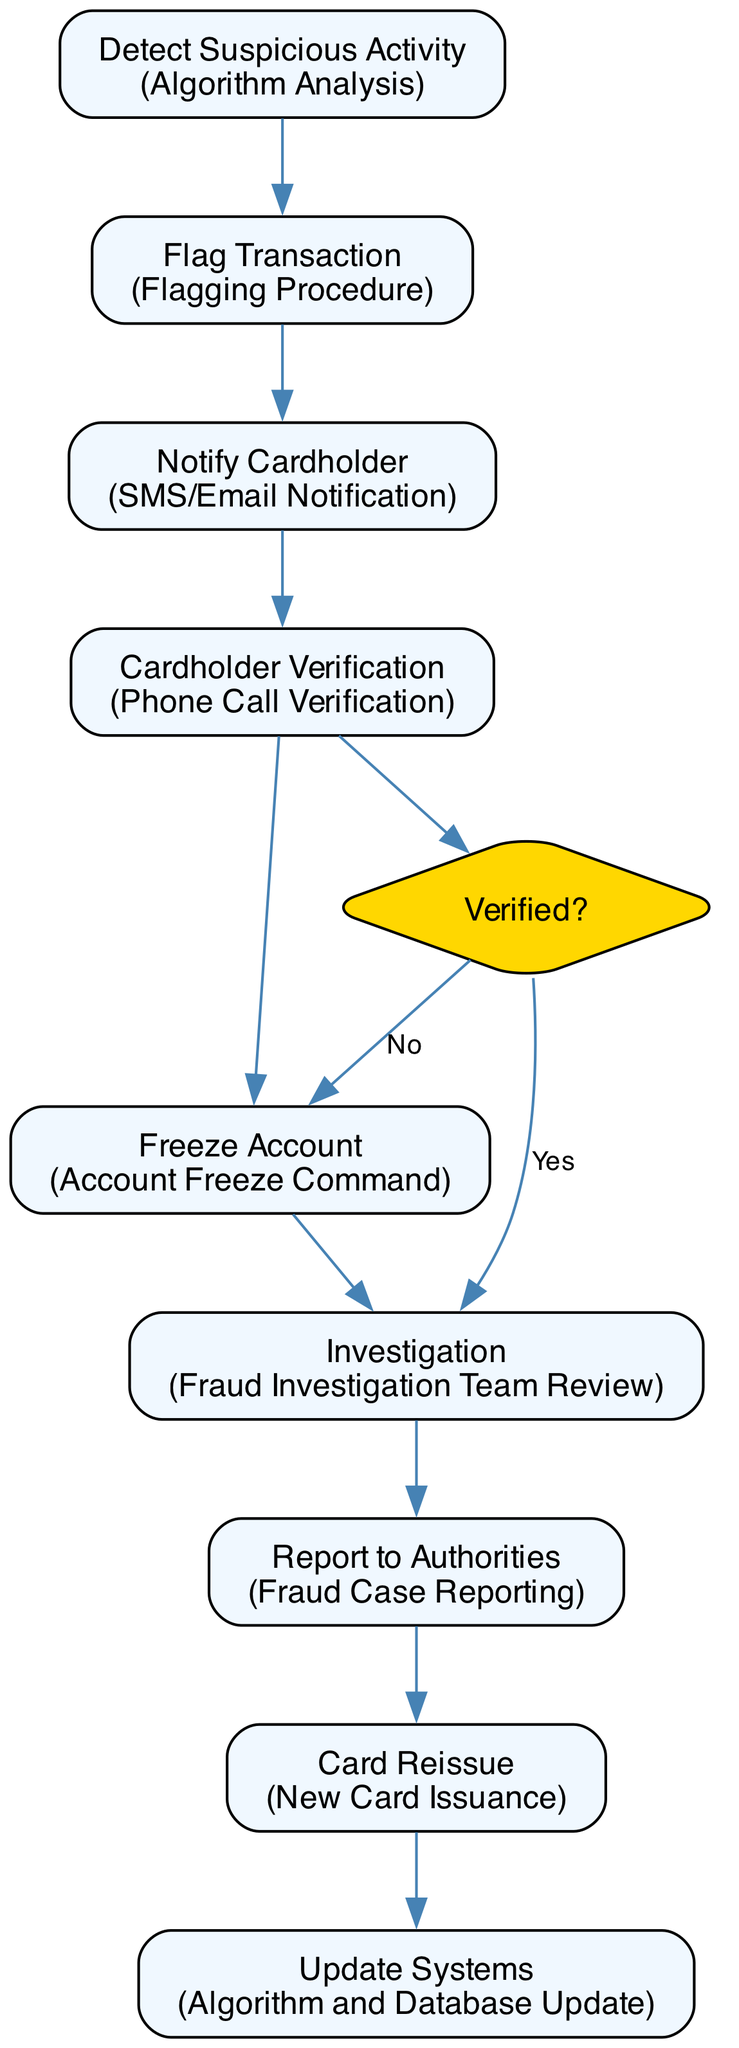What is the first step in the process? The first step in the flowchart is "Detect Suspicious Activity." It is located at the top of the flowchart as the initial action taken in the process of resolving credit card fraud.
Answer: Detect Suspicious Activity How many total steps are there in the diagram? The diagram lists a total of nine distinct steps. Each step is numbered sequentially, from 1 to 9, illustrating the entire process involved.
Answer: Nine What action is associated with the step "Freeze Account"? The action associated with the step "Freeze Account" is "Account Freeze Command." This describes the action taken if the cardholder's verification fails.
Answer: Account Freeze Command What comes after "Cardholder Verification"? After "Cardholder Verification," there is a decision node labeled "Verified?" This decision determines the next actions based on whether the transaction is verified as legitimate or not.
Answer: Verified? If the cardholder verification fails, what is the next step? If the cardholder verification fails (indicated by the decision node "Verified?" leading to "No"), the next step is "Freeze Account." This action means the cardholder's account will be temporarily frozen.
Answer: Freeze Account How many times does the term "Report" appear in the diagram? The term "Report" appears twice in the diagram. It is found in the steps "Report to Authorities" and "Fraud Case Reporting."
Answer: Two What happens if the verification is confirmed to be "Yes"? If the verification is confirmed to be "Yes," the flowchart continues to the step "Investigation," showing that further investigation is required for the flagged transaction.
Answer: Investigation What is the last step in the flowchart? The last step in the flowchart is "Update Systems," which indicates the final action taken to ensure the fraud detection systems are updated to reflect new patterns.
Answer: Update Systems 